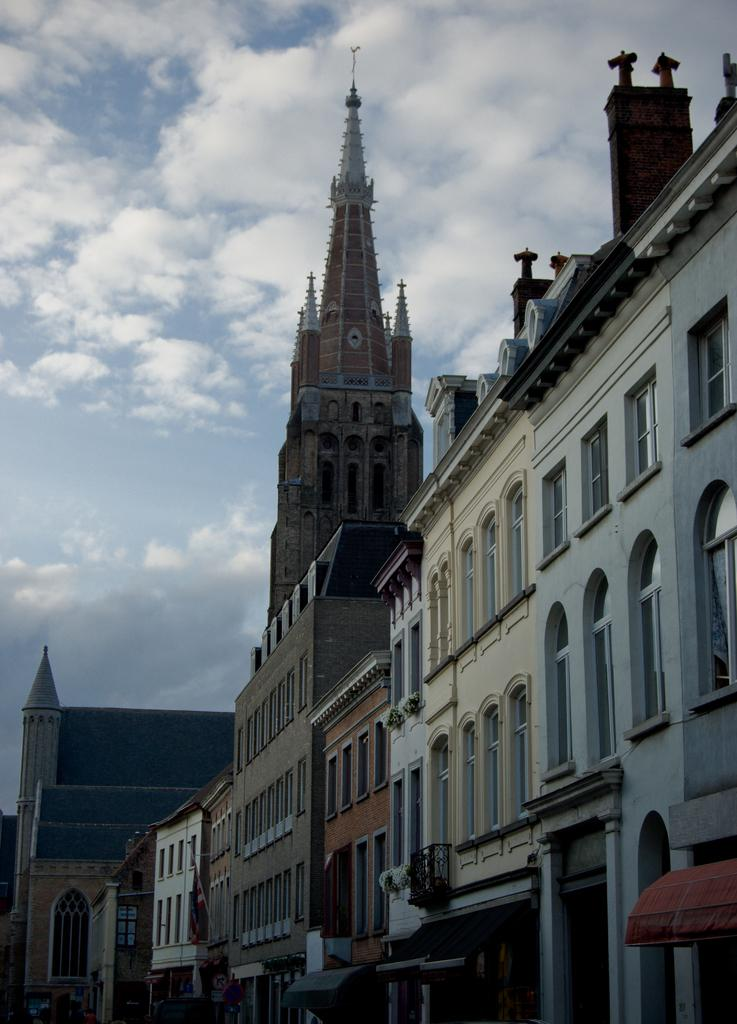What is the main subject of the image? The main subject of the image is many buildings. What feature can be observed on the buildings? The buildings have windows. What is visible in the background of the image? The sky is visible in the background of the image. What can be seen in the sky? There are clouds in the sky. Can you tell me how many receipts are scattered on the ground in the image? There are no receipts present in the image. What type of cakes are being used as bait for the birds in the image? There are no cakes or birds present in the image. 